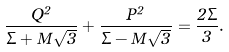Convert formula to latex. <formula><loc_0><loc_0><loc_500><loc_500>\frac { Q ^ { 2 } } { \Sigma + M \sqrt { 3 } } + \frac { P ^ { 2 } } { \Sigma - M \sqrt { 3 } } = \frac { 2 \Sigma } { 3 } .</formula> 